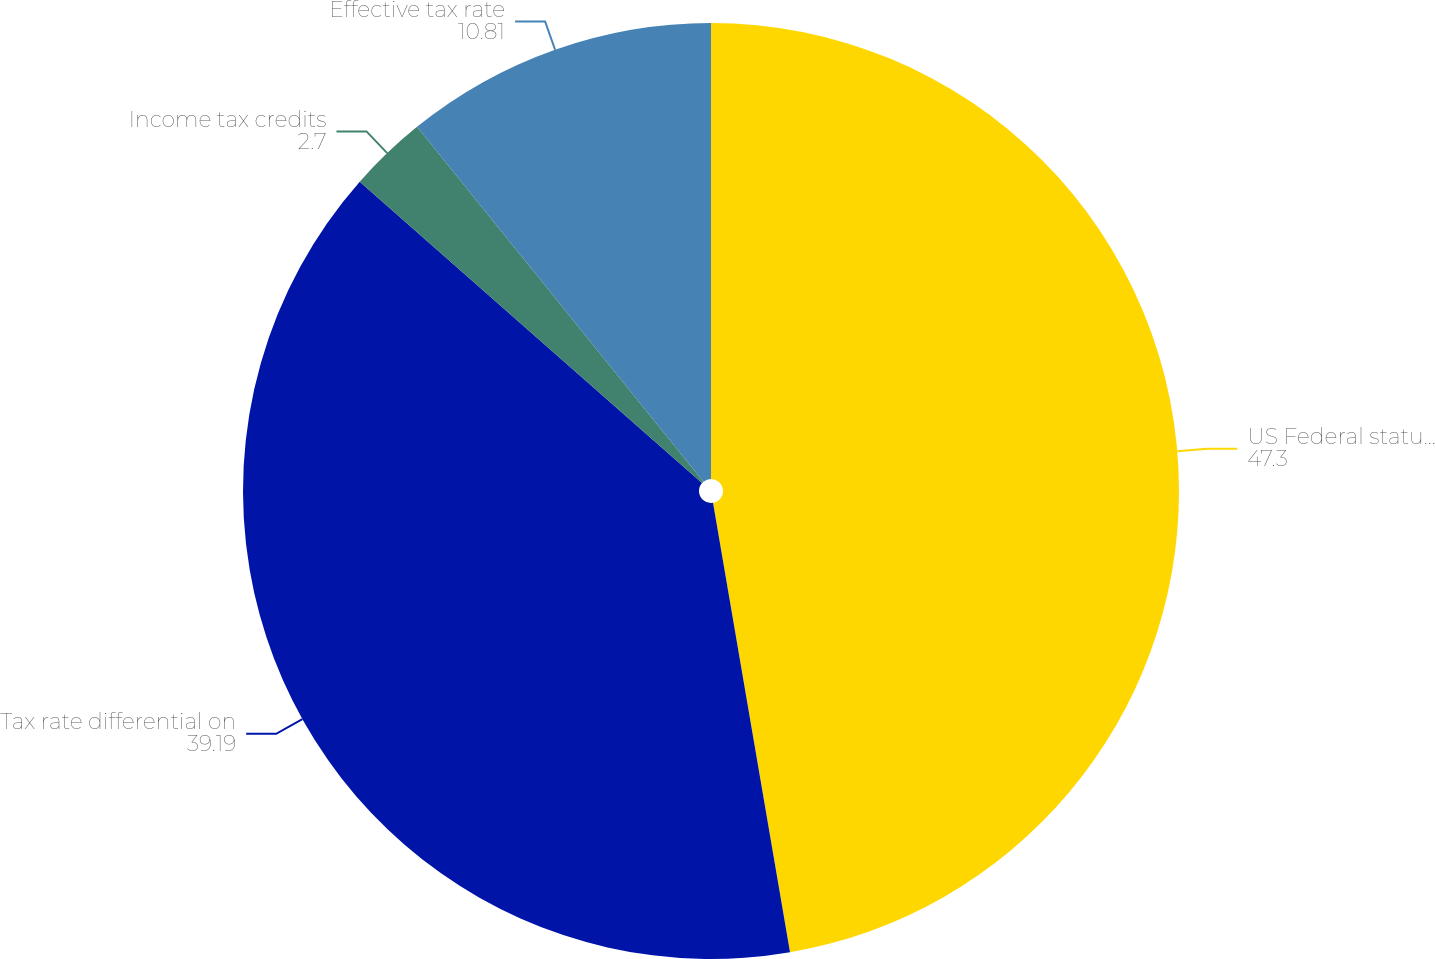<chart> <loc_0><loc_0><loc_500><loc_500><pie_chart><fcel>US Federal statutory rate<fcel>Tax rate differential on<fcel>Income tax credits<fcel>Effective tax rate<nl><fcel>47.3%<fcel>39.19%<fcel>2.7%<fcel>10.81%<nl></chart> 